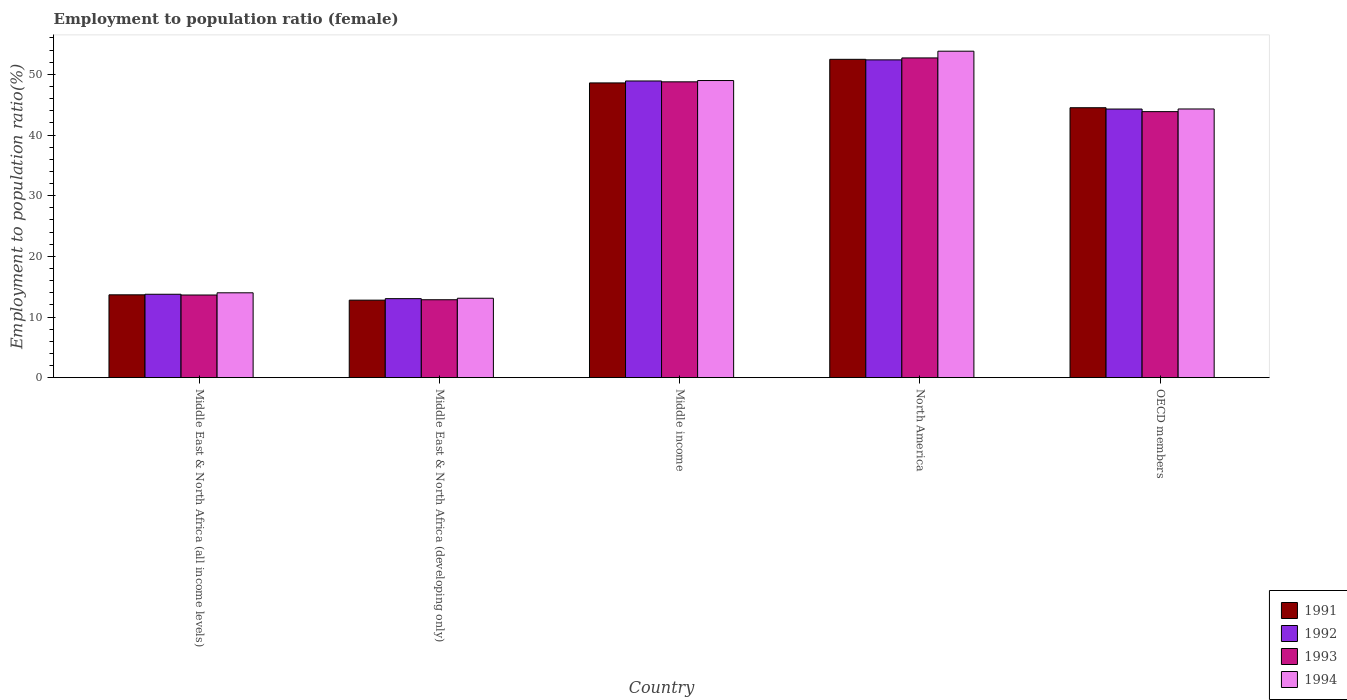How many groups of bars are there?
Provide a short and direct response. 5. How many bars are there on the 2nd tick from the left?
Provide a short and direct response. 4. What is the employment to population ratio in 1994 in Middle income?
Make the answer very short. 48.98. Across all countries, what is the maximum employment to population ratio in 1992?
Make the answer very short. 52.39. Across all countries, what is the minimum employment to population ratio in 1993?
Give a very brief answer. 12.84. In which country was the employment to population ratio in 1994 maximum?
Offer a very short reply. North America. In which country was the employment to population ratio in 1991 minimum?
Ensure brevity in your answer.  Middle East & North Africa (developing only). What is the total employment to population ratio in 1992 in the graph?
Keep it short and to the point. 172.36. What is the difference between the employment to population ratio in 1994 in Middle East & North Africa (all income levels) and that in North America?
Keep it short and to the point. -39.83. What is the difference between the employment to population ratio in 1994 in OECD members and the employment to population ratio in 1991 in Middle East & North Africa (developing only)?
Your response must be concise. 31.52. What is the average employment to population ratio in 1991 per country?
Provide a short and direct response. 34.4. What is the difference between the employment to population ratio of/in 1994 and employment to population ratio of/in 1993 in Middle East & North Africa (all income levels)?
Ensure brevity in your answer.  0.36. What is the ratio of the employment to population ratio in 1991 in Middle East & North Africa (all income levels) to that in North America?
Your answer should be compact. 0.26. Is the employment to population ratio in 1991 in Middle East & North Africa (all income levels) less than that in OECD members?
Offer a terse response. Yes. What is the difference between the highest and the second highest employment to population ratio in 1993?
Make the answer very short. 4.91. What is the difference between the highest and the lowest employment to population ratio in 1993?
Your response must be concise. 39.87. In how many countries, is the employment to population ratio in 1991 greater than the average employment to population ratio in 1991 taken over all countries?
Give a very brief answer. 3. Is it the case that in every country, the sum of the employment to population ratio in 1991 and employment to population ratio in 1992 is greater than the sum of employment to population ratio in 1994 and employment to population ratio in 1993?
Provide a succinct answer. No. What does the 1st bar from the left in Middle East & North Africa (all income levels) represents?
Your answer should be very brief. 1991. What does the 3rd bar from the right in Middle East & North Africa (developing only) represents?
Your answer should be very brief. 1992. Is it the case that in every country, the sum of the employment to population ratio in 1993 and employment to population ratio in 1992 is greater than the employment to population ratio in 1991?
Offer a terse response. Yes. How many bars are there?
Your response must be concise. 20. How many countries are there in the graph?
Keep it short and to the point. 5. Are the values on the major ticks of Y-axis written in scientific E-notation?
Offer a very short reply. No. Does the graph contain any zero values?
Keep it short and to the point. No. How many legend labels are there?
Give a very brief answer. 4. What is the title of the graph?
Offer a very short reply. Employment to population ratio (female). Does "1983" appear as one of the legend labels in the graph?
Make the answer very short. No. What is the Employment to population ratio(%) in 1991 in Middle East & North Africa (all income levels)?
Make the answer very short. 13.66. What is the Employment to population ratio(%) of 1992 in Middle East & North Africa (all income levels)?
Make the answer very short. 13.75. What is the Employment to population ratio(%) in 1993 in Middle East & North Africa (all income levels)?
Your answer should be very brief. 13.63. What is the Employment to population ratio(%) in 1994 in Middle East & North Africa (all income levels)?
Your answer should be very brief. 13.99. What is the Employment to population ratio(%) in 1991 in Middle East & North Africa (developing only)?
Your response must be concise. 12.78. What is the Employment to population ratio(%) of 1992 in Middle East & North Africa (developing only)?
Provide a short and direct response. 13.03. What is the Employment to population ratio(%) of 1993 in Middle East & North Africa (developing only)?
Provide a short and direct response. 12.84. What is the Employment to population ratio(%) of 1994 in Middle East & North Africa (developing only)?
Give a very brief answer. 13.09. What is the Employment to population ratio(%) in 1991 in Middle income?
Ensure brevity in your answer.  48.59. What is the Employment to population ratio(%) in 1992 in Middle income?
Your answer should be very brief. 48.91. What is the Employment to population ratio(%) of 1993 in Middle income?
Your answer should be compact. 48.77. What is the Employment to population ratio(%) of 1994 in Middle income?
Offer a very short reply. 48.98. What is the Employment to population ratio(%) of 1991 in North America?
Keep it short and to the point. 52.48. What is the Employment to population ratio(%) of 1992 in North America?
Provide a short and direct response. 52.39. What is the Employment to population ratio(%) of 1993 in North America?
Keep it short and to the point. 52.71. What is the Employment to population ratio(%) of 1994 in North America?
Provide a succinct answer. 53.82. What is the Employment to population ratio(%) of 1991 in OECD members?
Provide a succinct answer. 44.5. What is the Employment to population ratio(%) of 1992 in OECD members?
Give a very brief answer. 44.28. What is the Employment to population ratio(%) in 1993 in OECD members?
Provide a short and direct response. 43.86. What is the Employment to population ratio(%) of 1994 in OECD members?
Offer a very short reply. 44.3. Across all countries, what is the maximum Employment to population ratio(%) in 1991?
Offer a terse response. 52.48. Across all countries, what is the maximum Employment to population ratio(%) of 1992?
Your answer should be compact. 52.39. Across all countries, what is the maximum Employment to population ratio(%) in 1993?
Give a very brief answer. 52.71. Across all countries, what is the maximum Employment to population ratio(%) of 1994?
Offer a very short reply. 53.82. Across all countries, what is the minimum Employment to population ratio(%) in 1991?
Keep it short and to the point. 12.78. Across all countries, what is the minimum Employment to population ratio(%) of 1992?
Offer a very short reply. 13.03. Across all countries, what is the minimum Employment to population ratio(%) in 1993?
Ensure brevity in your answer.  12.84. Across all countries, what is the minimum Employment to population ratio(%) in 1994?
Provide a short and direct response. 13.09. What is the total Employment to population ratio(%) in 1991 in the graph?
Make the answer very short. 172. What is the total Employment to population ratio(%) of 1992 in the graph?
Ensure brevity in your answer.  172.36. What is the total Employment to population ratio(%) of 1993 in the graph?
Provide a succinct answer. 171.81. What is the total Employment to population ratio(%) in 1994 in the graph?
Offer a very short reply. 174.18. What is the difference between the Employment to population ratio(%) of 1991 in Middle East & North Africa (all income levels) and that in Middle East & North Africa (developing only)?
Give a very brief answer. 0.88. What is the difference between the Employment to population ratio(%) of 1992 in Middle East & North Africa (all income levels) and that in Middle East & North Africa (developing only)?
Make the answer very short. 0.72. What is the difference between the Employment to population ratio(%) of 1993 in Middle East & North Africa (all income levels) and that in Middle East & North Africa (developing only)?
Provide a short and direct response. 0.78. What is the difference between the Employment to population ratio(%) of 1994 in Middle East & North Africa (all income levels) and that in Middle East & North Africa (developing only)?
Your answer should be very brief. 0.9. What is the difference between the Employment to population ratio(%) in 1991 in Middle East & North Africa (all income levels) and that in Middle income?
Keep it short and to the point. -34.93. What is the difference between the Employment to population ratio(%) in 1992 in Middle East & North Africa (all income levels) and that in Middle income?
Provide a succinct answer. -35.16. What is the difference between the Employment to population ratio(%) in 1993 in Middle East & North Africa (all income levels) and that in Middle income?
Offer a very short reply. -35.14. What is the difference between the Employment to population ratio(%) of 1994 in Middle East & North Africa (all income levels) and that in Middle income?
Your response must be concise. -35. What is the difference between the Employment to population ratio(%) of 1991 in Middle East & North Africa (all income levels) and that in North America?
Keep it short and to the point. -38.82. What is the difference between the Employment to population ratio(%) of 1992 in Middle East & North Africa (all income levels) and that in North America?
Offer a terse response. -38.64. What is the difference between the Employment to population ratio(%) of 1993 in Middle East & North Africa (all income levels) and that in North America?
Provide a succinct answer. -39.08. What is the difference between the Employment to population ratio(%) in 1994 in Middle East & North Africa (all income levels) and that in North America?
Provide a short and direct response. -39.83. What is the difference between the Employment to population ratio(%) in 1991 in Middle East & North Africa (all income levels) and that in OECD members?
Make the answer very short. -30.84. What is the difference between the Employment to population ratio(%) in 1992 in Middle East & North Africa (all income levels) and that in OECD members?
Provide a succinct answer. -30.54. What is the difference between the Employment to population ratio(%) in 1993 in Middle East & North Africa (all income levels) and that in OECD members?
Ensure brevity in your answer.  -30.23. What is the difference between the Employment to population ratio(%) of 1994 in Middle East & North Africa (all income levels) and that in OECD members?
Ensure brevity in your answer.  -30.31. What is the difference between the Employment to population ratio(%) of 1991 in Middle East & North Africa (developing only) and that in Middle income?
Your answer should be very brief. -35.81. What is the difference between the Employment to population ratio(%) in 1992 in Middle East & North Africa (developing only) and that in Middle income?
Your answer should be very brief. -35.88. What is the difference between the Employment to population ratio(%) in 1993 in Middle East & North Africa (developing only) and that in Middle income?
Your answer should be very brief. -35.93. What is the difference between the Employment to population ratio(%) in 1994 in Middle East & North Africa (developing only) and that in Middle income?
Make the answer very short. -35.89. What is the difference between the Employment to population ratio(%) of 1991 in Middle East & North Africa (developing only) and that in North America?
Ensure brevity in your answer.  -39.7. What is the difference between the Employment to population ratio(%) in 1992 in Middle East & North Africa (developing only) and that in North America?
Give a very brief answer. -39.36. What is the difference between the Employment to population ratio(%) in 1993 in Middle East & North Africa (developing only) and that in North America?
Give a very brief answer. -39.87. What is the difference between the Employment to population ratio(%) of 1994 in Middle East & North Africa (developing only) and that in North America?
Offer a terse response. -40.73. What is the difference between the Employment to population ratio(%) in 1991 in Middle East & North Africa (developing only) and that in OECD members?
Offer a very short reply. -31.72. What is the difference between the Employment to population ratio(%) in 1992 in Middle East & North Africa (developing only) and that in OECD members?
Provide a succinct answer. -31.26. What is the difference between the Employment to population ratio(%) of 1993 in Middle East & North Africa (developing only) and that in OECD members?
Your response must be concise. -31.01. What is the difference between the Employment to population ratio(%) of 1994 in Middle East & North Africa (developing only) and that in OECD members?
Your answer should be very brief. -31.2. What is the difference between the Employment to population ratio(%) of 1991 in Middle income and that in North America?
Your answer should be compact. -3.89. What is the difference between the Employment to population ratio(%) of 1992 in Middle income and that in North America?
Ensure brevity in your answer.  -3.48. What is the difference between the Employment to population ratio(%) of 1993 in Middle income and that in North America?
Offer a very short reply. -3.94. What is the difference between the Employment to population ratio(%) of 1994 in Middle income and that in North America?
Offer a terse response. -4.84. What is the difference between the Employment to population ratio(%) of 1991 in Middle income and that in OECD members?
Keep it short and to the point. 4.09. What is the difference between the Employment to population ratio(%) of 1992 in Middle income and that in OECD members?
Provide a short and direct response. 4.63. What is the difference between the Employment to population ratio(%) of 1993 in Middle income and that in OECD members?
Make the answer very short. 4.91. What is the difference between the Employment to population ratio(%) in 1994 in Middle income and that in OECD members?
Offer a very short reply. 4.69. What is the difference between the Employment to population ratio(%) in 1991 in North America and that in OECD members?
Provide a succinct answer. 7.98. What is the difference between the Employment to population ratio(%) of 1992 in North America and that in OECD members?
Ensure brevity in your answer.  8.1. What is the difference between the Employment to population ratio(%) in 1993 in North America and that in OECD members?
Offer a terse response. 8.85. What is the difference between the Employment to population ratio(%) of 1994 in North America and that in OECD members?
Provide a short and direct response. 9.52. What is the difference between the Employment to population ratio(%) in 1991 in Middle East & North Africa (all income levels) and the Employment to population ratio(%) in 1992 in Middle East & North Africa (developing only)?
Your response must be concise. 0.63. What is the difference between the Employment to population ratio(%) of 1991 in Middle East & North Africa (all income levels) and the Employment to population ratio(%) of 1993 in Middle East & North Africa (developing only)?
Give a very brief answer. 0.81. What is the difference between the Employment to population ratio(%) of 1991 in Middle East & North Africa (all income levels) and the Employment to population ratio(%) of 1994 in Middle East & North Africa (developing only)?
Make the answer very short. 0.56. What is the difference between the Employment to population ratio(%) in 1992 in Middle East & North Africa (all income levels) and the Employment to population ratio(%) in 1993 in Middle East & North Africa (developing only)?
Ensure brevity in your answer.  0.9. What is the difference between the Employment to population ratio(%) of 1992 in Middle East & North Africa (all income levels) and the Employment to population ratio(%) of 1994 in Middle East & North Africa (developing only)?
Provide a short and direct response. 0.66. What is the difference between the Employment to population ratio(%) of 1993 in Middle East & North Africa (all income levels) and the Employment to population ratio(%) of 1994 in Middle East & North Africa (developing only)?
Offer a very short reply. 0.53. What is the difference between the Employment to population ratio(%) in 1991 in Middle East & North Africa (all income levels) and the Employment to population ratio(%) in 1992 in Middle income?
Keep it short and to the point. -35.25. What is the difference between the Employment to population ratio(%) in 1991 in Middle East & North Africa (all income levels) and the Employment to population ratio(%) in 1993 in Middle income?
Provide a short and direct response. -35.11. What is the difference between the Employment to population ratio(%) of 1991 in Middle East & North Africa (all income levels) and the Employment to population ratio(%) of 1994 in Middle income?
Provide a succinct answer. -35.33. What is the difference between the Employment to population ratio(%) in 1992 in Middle East & North Africa (all income levels) and the Employment to population ratio(%) in 1993 in Middle income?
Provide a short and direct response. -35.02. What is the difference between the Employment to population ratio(%) of 1992 in Middle East & North Africa (all income levels) and the Employment to population ratio(%) of 1994 in Middle income?
Offer a very short reply. -35.23. What is the difference between the Employment to population ratio(%) of 1993 in Middle East & North Africa (all income levels) and the Employment to population ratio(%) of 1994 in Middle income?
Provide a short and direct response. -35.36. What is the difference between the Employment to population ratio(%) in 1991 in Middle East & North Africa (all income levels) and the Employment to population ratio(%) in 1992 in North America?
Your response must be concise. -38.73. What is the difference between the Employment to population ratio(%) of 1991 in Middle East & North Africa (all income levels) and the Employment to population ratio(%) of 1993 in North America?
Your response must be concise. -39.05. What is the difference between the Employment to population ratio(%) in 1991 in Middle East & North Africa (all income levels) and the Employment to population ratio(%) in 1994 in North America?
Ensure brevity in your answer.  -40.16. What is the difference between the Employment to population ratio(%) of 1992 in Middle East & North Africa (all income levels) and the Employment to population ratio(%) of 1993 in North America?
Your answer should be very brief. -38.96. What is the difference between the Employment to population ratio(%) in 1992 in Middle East & North Africa (all income levels) and the Employment to population ratio(%) in 1994 in North America?
Give a very brief answer. -40.07. What is the difference between the Employment to population ratio(%) of 1993 in Middle East & North Africa (all income levels) and the Employment to population ratio(%) of 1994 in North America?
Your answer should be very brief. -40.19. What is the difference between the Employment to population ratio(%) of 1991 in Middle East & North Africa (all income levels) and the Employment to population ratio(%) of 1992 in OECD members?
Provide a succinct answer. -30.63. What is the difference between the Employment to population ratio(%) in 1991 in Middle East & North Africa (all income levels) and the Employment to population ratio(%) in 1993 in OECD members?
Offer a terse response. -30.2. What is the difference between the Employment to population ratio(%) of 1991 in Middle East & North Africa (all income levels) and the Employment to population ratio(%) of 1994 in OECD members?
Give a very brief answer. -30.64. What is the difference between the Employment to population ratio(%) in 1992 in Middle East & North Africa (all income levels) and the Employment to population ratio(%) in 1993 in OECD members?
Offer a very short reply. -30.11. What is the difference between the Employment to population ratio(%) in 1992 in Middle East & North Africa (all income levels) and the Employment to population ratio(%) in 1994 in OECD members?
Your response must be concise. -30.55. What is the difference between the Employment to population ratio(%) in 1993 in Middle East & North Africa (all income levels) and the Employment to population ratio(%) in 1994 in OECD members?
Your answer should be compact. -30.67. What is the difference between the Employment to population ratio(%) of 1991 in Middle East & North Africa (developing only) and the Employment to population ratio(%) of 1992 in Middle income?
Provide a succinct answer. -36.13. What is the difference between the Employment to population ratio(%) of 1991 in Middle East & North Africa (developing only) and the Employment to population ratio(%) of 1993 in Middle income?
Your answer should be compact. -35.99. What is the difference between the Employment to population ratio(%) in 1991 in Middle East & North Africa (developing only) and the Employment to population ratio(%) in 1994 in Middle income?
Provide a succinct answer. -36.21. What is the difference between the Employment to population ratio(%) in 1992 in Middle East & North Africa (developing only) and the Employment to population ratio(%) in 1993 in Middle income?
Your response must be concise. -35.74. What is the difference between the Employment to population ratio(%) in 1992 in Middle East & North Africa (developing only) and the Employment to population ratio(%) in 1994 in Middle income?
Provide a succinct answer. -35.96. What is the difference between the Employment to population ratio(%) in 1993 in Middle East & North Africa (developing only) and the Employment to population ratio(%) in 1994 in Middle income?
Provide a short and direct response. -36.14. What is the difference between the Employment to population ratio(%) of 1991 in Middle East & North Africa (developing only) and the Employment to population ratio(%) of 1992 in North America?
Your response must be concise. -39.61. What is the difference between the Employment to population ratio(%) in 1991 in Middle East & North Africa (developing only) and the Employment to population ratio(%) in 1993 in North America?
Make the answer very short. -39.93. What is the difference between the Employment to population ratio(%) of 1991 in Middle East & North Africa (developing only) and the Employment to population ratio(%) of 1994 in North America?
Give a very brief answer. -41.04. What is the difference between the Employment to population ratio(%) in 1992 in Middle East & North Africa (developing only) and the Employment to population ratio(%) in 1993 in North America?
Offer a very short reply. -39.68. What is the difference between the Employment to population ratio(%) of 1992 in Middle East & North Africa (developing only) and the Employment to population ratio(%) of 1994 in North America?
Your response must be concise. -40.79. What is the difference between the Employment to population ratio(%) in 1993 in Middle East & North Africa (developing only) and the Employment to population ratio(%) in 1994 in North America?
Your answer should be very brief. -40.97. What is the difference between the Employment to population ratio(%) of 1991 in Middle East & North Africa (developing only) and the Employment to population ratio(%) of 1992 in OECD members?
Offer a terse response. -31.51. What is the difference between the Employment to population ratio(%) of 1991 in Middle East & North Africa (developing only) and the Employment to population ratio(%) of 1993 in OECD members?
Your answer should be very brief. -31.08. What is the difference between the Employment to population ratio(%) in 1991 in Middle East & North Africa (developing only) and the Employment to population ratio(%) in 1994 in OECD members?
Provide a succinct answer. -31.52. What is the difference between the Employment to population ratio(%) of 1992 in Middle East & North Africa (developing only) and the Employment to population ratio(%) of 1993 in OECD members?
Your response must be concise. -30.83. What is the difference between the Employment to population ratio(%) of 1992 in Middle East & North Africa (developing only) and the Employment to population ratio(%) of 1994 in OECD members?
Your response must be concise. -31.27. What is the difference between the Employment to population ratio(%) in 1993 in Middle East & North Africa (developing only) and the Employment to population ratio(%) in 1994 in OECD members?
Offer a terse response. -31.45. What is the difference between the Employment to population ratio(%) in 1991 in Middle income and the Employment to population ratio(%) in 1992 in North America?
Make the answer very short. -3.8. What is the difference between the Employment to population ratio(%) of 1991 in Middle income and the Employment to population ratio(%) of 1993 in North America?
Make the answer very short. -4.12. What is the difference between the Employment to population ratio(%) in 1991 in Middle income and the Employment to population ratio(%) in 1994 in North America?
Offer a terse response. -5.23. What is the difference between the Employment to population ratio(%) in 1992 in Middle income and the Employment to population ratio(%) in 1993 in North America?
Your response must be concise. -3.8. What is the difference between the Employment to population ratio(%) of 1992 in Middle income and the Employment to population ratio(%) of 1994 in North America?
Keep it short and to the point. -4.91. What is the difference between the Employment to population ratio(%) in 1993 in Middle income and the Employment to population ratio(%) in 1994 in North America?
Make the answer very short. -5.05. What is the difference between the Employment to population ratio(%) of 1991 in Middle income and the Employment to population ratio(%) of 1992 in OECD members?
Provide a short and direct response. 4.31. What is the difference between the Employment to population ratio(%) of 1991 in Middle income and the Employment to population ratio(%) of 1993 in OECD members?
Offer a terse response. 4.73. What is the difference between the Employment to population ratio(%) of 1991 in Middle income and the Employment to population ratio(%) of 1994 in OECD members?
Your response must be concise. 4.29. What is the difference between the Employment to population ratio(%) of 1992 in Middle income and the Employment to population ratio(%) of 1993 in OECD members?
Provide a short and direct response. 5.05. What is the difference between the Employment to population ratio(%) of 1992 in Middle income and the Employment to population ratio(%) of 1994 in OECD members?
Your answer should be very brief. 4.62. What is the difference between the Employment to population ratio(%) of 1993 in Middle income and the Employment to population ratio(%) of 1994 in OECD members?
Your answer should be very brief. 4.47. What is the difference between the Employment to population ratio(%) in 1991 in North America and the Employment to population ratio(%) in 1992 in OECD members?
Keep it short and to the point. 8.2. What is the difference between the Employment to population ratio(%) in 1991 in North America and the Employment to population ratio(%) in 1993 in OECD members?
Provide a succinct answer. 8.62. What is the difference between the Employment to population ratio(%) in 1991 in North America and the Employment to population ratio(%) in 1994 in OECD members?
Provide a short and direct response. 8.18. What is the difference between the Employment to population ratio(%) of 1992 in North America and the Employment to population ratio(%) of 1993 in OECD members?
Provide a succinct answer. 8.53. What is the difference between the Employment to population ratio(%) in 1992 in North America and the Employment to population ratio(%) in 1994 in OECD members?
Make the answer very short. 8.09. What is the difference between the Employment to population ratio(%) of 1993 in North America and the Employment to population ratio(%) of 1994 in OECD members?
Offer a terse response. 8.41. What is the average Employment to population ratio(%) in 1991 per country?
Offer a very short reply. 34.4. What is the average Employment to population ratio(%) of 1992 per country?
Keep it short and to the point. 34.47. What is the average Employment to population ratio(%) in 1993 per country?
Provide a short and direct response. 34.36. What is the average Employment to population ratio(%) in 1994 per country?
Provide a succinct answer. 34.84. What is the difference between the Employment to population ratio(%) of 1991 and Employment to population ratio(%) of 1992 in Middle East & North Africa (all income levels)?
Your response must be concise. -0.09. What is the difference between the Employment to population ratio(%) of 1991 and Employment to population ratio(%) of 1994 in Middle East & North Africa (all income levels)?
Your answer should be compact. -0.33. What is the difference between the Employment to population ratio(%) in 1992 and Employment to population ratio(%) in 1993 in Middle East & North Africa (all income levels)?
Provide a succinct answer. 0.12. What is the difference between the Employment to population ratio(%) in 1992 and Employment to population ratio(%) in 1994 in Middle East & North Africa (all income levels)?
Provide a short and direct response. -0.24. What is the difference between the Employment to population ratio(%) of 1993 and Employment to population ratio(%) of 1994 in Middle East & North Africa (all income levels)?
Make the answer very short. -0.36. What is the difference between the Employment to population ratio(%) of 1991 and Employment to population ratio(%) of 1992 in Middle East & North Africa (developing only)?
Give a very brief answer. -0.25. What is the difference between the Employment to population ratio(%) in 1991 and Employment to population ratio(%) in 1993 in Middle East & North Africa (developing only)?
Your response must be concise. -0.07. What is the difference between the Employment to population ratio(%) of 1991 and Employment to population ratio(%) of 1994 in Middle East & North Africa (developing only)?
Your answer should be very brief. -0.31. What is the difference between the Employment to population ratio(%) in 1992 and Employment to population ratio(%) in 1993 in Middle East & North Africa (developing only)?
Your answer should be compact. 0.18. What is the difference between the Employment to population ratio(%) of 1992 and Employment to population ratio(%) of 1994 in Middle East & North Africa (developing only)?
Provide a succinct answer. -0.07. What is the difference between the Employment to population ratio(%) of 1993 and Employment to population ratio(%) of 1994 in Middle East & North Africa (developing only)?
Provide a succinct answer. -0.25. What is the difference between the Employment to population ratio(%) of 1991 and Employment to population ratio(%) of 1992 in Middle income?
Give a very brief answer. -0.32. What is the difference between the Employment to population ratio(%) in 1991 and Employment to population ratio(%) in 1993 in Middle income?
Your answer should be very brief. -0.18. What is the difference between the Employment to population ratio(%) in 1991 and Employment to population ratio(%) in 1994 in Middle income?
Offer a very short reply. -0.39. What is the difference between the Employment to population ratio(%) in 1992 and Employment to population ratio(%) in 1993 in Middle income?
Keep it short and to the point. 0.14. What is the difference between the Employment to population ratio(%) in 1992 and Employment to population ratio(%) in 1994 in Middle income?
Provide a succinct answer. -0.07. What is the difference between the Employment to population ratio(%) in 1993 and Employment to population ratio(%) in 1994 in Middle income?
Keep it short and to the point. -0.21. What is the difference between the Employment to population ratio(%) in 1991 and Employment to population ratio(%) in 1992 in North America?
Offer a very short reply. 0.09. What is the difference between the Employment to population ratio(%) of 1991 and Employment to population ratio(%) of 1993 in North America?
Make the answer very short. -0.23. What is the difference between the Employment to population ratio(%) of 1991 and Employment to population ratio(%) of 1994 in North America?
Provide a short and direct response. -1.34. What is the difference between the Employment to population ratio(%) of 1992 and Employment to population ratio(%) of 1993 in North America?
Ensure brevity in your answer.  -0.32. What is the difference between the Employment to population ratio(%) of 1992 and Employment to population ratio(%) of 1994 in North America?
Your answer should be very brief. -1.43. What is the difference between the Employment to population ratio(%) in 1993 and Employment to population ratio(%) in 1994 in North America?
Offer a very short reply. -1.11. What is the difference between the Employment to population ratio(%) of 1991 and Employment to population ratio(%) of 1992 in OECD members?
Your answer should be compact. 0.21. What is the difference between the Employment to population ratio(%) of 1991 and Employment to population ratio(%) of 1993 in OECD members?
Offer a very short reply. 0.64. What is the difference between the Employment to population ratio(%) in 1991 and Employment to population ratio(%) in 1994 in OECD members?
Provide a succinct answer. 0.2. What is the difference between the Employment to population ratio(%) in 1992 and Employment to population ratio(%) in 1993 in OECD members?
Offer a very short reply. 0.43. What is the difference between the Employment to population ratio(%) in 1992 and Employment to population ratio(%) in 1994 in OECD members?
Your answer should be very brief. -0.01. What is the difference between the Employment to population ratio(%) in 1993 and Employment to population ratio(%) in 1994 in OECD members?
Your answer should be compact. -0.44. What is the ratio of the Employment to population ratio(%) of 1991 in Middle East & North Africa (all income levels) to that in Middle East & North Africa (developing only)?
Your answer should be compact. 1.07. What is the ratio of the Employment to population ratio(%) of 1992 in Middle East & North Africa (all income levels) to that in Middle East & North Africa (developing only)?
Give a very brief answer. 1.06. What is the ratio of the Employment to population ratio(%) in 1993 in Middle East & North Africa (all income levels) to that in Middle East & North Africa (developing only)?
Ensure brevity in your answer.  1.06. What is the ratio of the Employment to population ratio(%) of 1994 in Middle East & North Africa (all income levels) to that in Middle East & North Africa (developing only)?
Your response must be concise. 1.07. What is the ratio of the Employment to population ratio(%) in 1991 in Middle East & North Africa (all income levels) to that in Middle income?
Offer a terse response. 0.28. What is the ratio of the Employment to population ratio(%) of 1992 in Middle East & North Africa (all income levels) to that in Middle income?
Offer a very short reply. 0.28. What is the ratio of the Employment to population ratio(%) of 1993 in Middle East & North Africa (all income levels) to that in Middle income?
Your answer should be very brief. 0.28. What is the ratio of the Employment to population ratio(%) in 1994 in Middle East & North Africa (all income levels) to that in Middle income?
Keep it short and to the point. 0.29. What is the ratio of the Employment to population ratio(%) in 1991 in Middle East & North Africa (all income levels) to that in North America?
Keep it short and to the point. 0.26. What is the ratio of the Employment to population ratio(%) of 1992 in Middle East & North Africa (all income levels) to that in North America?
Make the answer very short. 0.26. What is the ratio of the Employment to population ratio(%) of 1993 in Middle East & North Africa (all income levels) to that in North America?
Your answer should be compact. 0.26. What is the ratio of the Employment to population ratio(%) in 1994 in Middle East & North Africa (all income levels) to that in North America?
Offer a terse response. 0.26. What is the ratio of the Employment to population ratio(%) in 1991 in Middle East & North Africa (all income levels) to that in OECD members?
Provide a succinct answer. 0.31. What is the ratio of the Employment to population ratio(%) in 1992 in Middle East & North Africa (all income levels) to that in OECD members?
Offer a terse response. 0.31. What is the ratio of the Employment to population ratio(%) of 1993 in Middle East & North Africa (all income levels) to that in OECD members?
Your answer should be compact. 0.31. What is the ratio of the Employment to population ratio(%) in 1994 in Middle East & North Africa (all income levels) to that in OECD members?
Keep it short and to the point. 0.32. What is the ratio of the Employment to population ratio(%) in 1991 in Middle East & North Africa (developing only) to that in Middle income?
Your answer should be very brief. 0.26. What is the ratio of the Employment to population ratio(%) in 1992 in Middle East & North Africa (developing only) to that in Middle income?
Your answer should be compact. 0.27. What is the ratio of the Employment to population ratio(%) in 1993 in Middle East & North Africa (developing only) to that in Middle income?
Your answer should be very brief. 0.26. What is the ratio of the Employment to population ratio(%) in 1994 in Middle East & North Africa (developing only) to that in Middle income?
Give a very brief answer. 0.27. What is the ratio of the Employment to population ratio(%) of 1991 in Middle East & North Africa (developing only) to that in North America?
Offer a terse response. 0.24. What is the ratio of the Employment to population ratio(%) of 1992 in Middle East & North Africa (developing only) to that in North America?
Give a very brief answer. 0.25. What is the ratio of the Employment to population ratio(%) of 1993 in Middle East & North Africa (developing only) to that in North America?
Your response must be concise. 0.24. What is the ratio of the Employment to population ratio(%) in 1994 in Middle East & North Africa (developing only) to that in North America?
Ensure brevity in your answer.  0.24. What is the ratio of the Employment to population ratio(%) in 1991 in Middle East & North Africa (developing only) to that in OECD members?
Give a very brief answer. 0.29. What is the ratio of the Employment to population ratio(%) in 1992 in Middle East & North Africa (developing only) to that in OECD members?
Your answer should be very brief. 0.29. What is the ratio of the Employment to population ratio(%) of 1993 in Middle East & North Africa (developing only) to that in OECD members?
Provide a succinct answer. 0.29. What is the ratio of the Employment to population ratio(%) of 1994 in Middle East & North Africa (developing only) to that in OECD members?
Offer a very short reply. 0.3. What is the ratio of the Employment to population ratio(%) of 1991 in Middle income to that in North America?
Offer a terse response. 0.93. What is the ratio of the Employment to population ratio(%) in 1992 in Middle income to that in North America?
Offer a very short reply. 0.93. What is the ratio of the Employment to population ratio(%) in 1993 in Middle income to that in North America?
Your answer should be compact. 0.93. What is the ratio of the Employment to population ratio(%) in 1994 in Middle income to that in North America?
Your response must be concise. 0.91. What is the ratio of the Employment to population ratio(%) of 1991 in Middle income to that in OECD members?
Ensure brevity in your answer.  1.09. What is the ratio of the Employment to population ratio(%) of 1992 in Middle income to that in OECD members?
Ensure brevity in your answer.  1.1. What is the ratio of the Employment to population ratio(%) in 1993 in Middle income to that in OECD members?
Your response must be concise. 1.11. What is the ratio of the Employment to population ratio(%) of 1994 in Middle income to that in OECD members?
Make the answer very short. 1.11. What is the ratio of the Employment to population ratio(%) of 1991 in North America to that in OECD members?
Provide a succinct answer. 1.18. What is the ratio of the Employment to population ratio(%) of 1992 in North America to that in OECD members?
Provide a short and direct response. 1.18. What is the ratio of the Employment to population ratio(%) in 1993 in North America to that in OECD members?
Keep it short and to the point. 1.2. What is the ratio of the Employment to population ratio(%) in 1994 in North America to that in OECD members?
Your answer should be compact. 1.22. What is the difference between the highest and the second highest Employment to population ratio(%) of 1991?
Give a very brief answer. 3.89. What is the difference between the highest and the second highest Employment to population ratio(%) of 1992?
Your response must be concise. 3.48. What is the difference between the highest and the second highest Employment to population ratio(%) in 1993?
Your answer should be very brief. 3.94. What is the difference between the highest and the second highest Employment to population ratio(%) of 1994?
Your answer should be compact. 4.84. What is the difference between the highest and the lowest Employment to population ratio(%) of 1991?
Provide a short and direct response. 39.7. What is the difference between the highest and the lowest Employment to population ratio(%) in 1992?
Your answer should be compact. 39.36. What is the difference between the highest and the lowest Employment to population ratio(%) in 1993?
Make the answer very short. 39.87. What is the difference between the highest and the lowest Employment to population ratio(%) of 1994?
Provide a succinct answer. 40.73. 